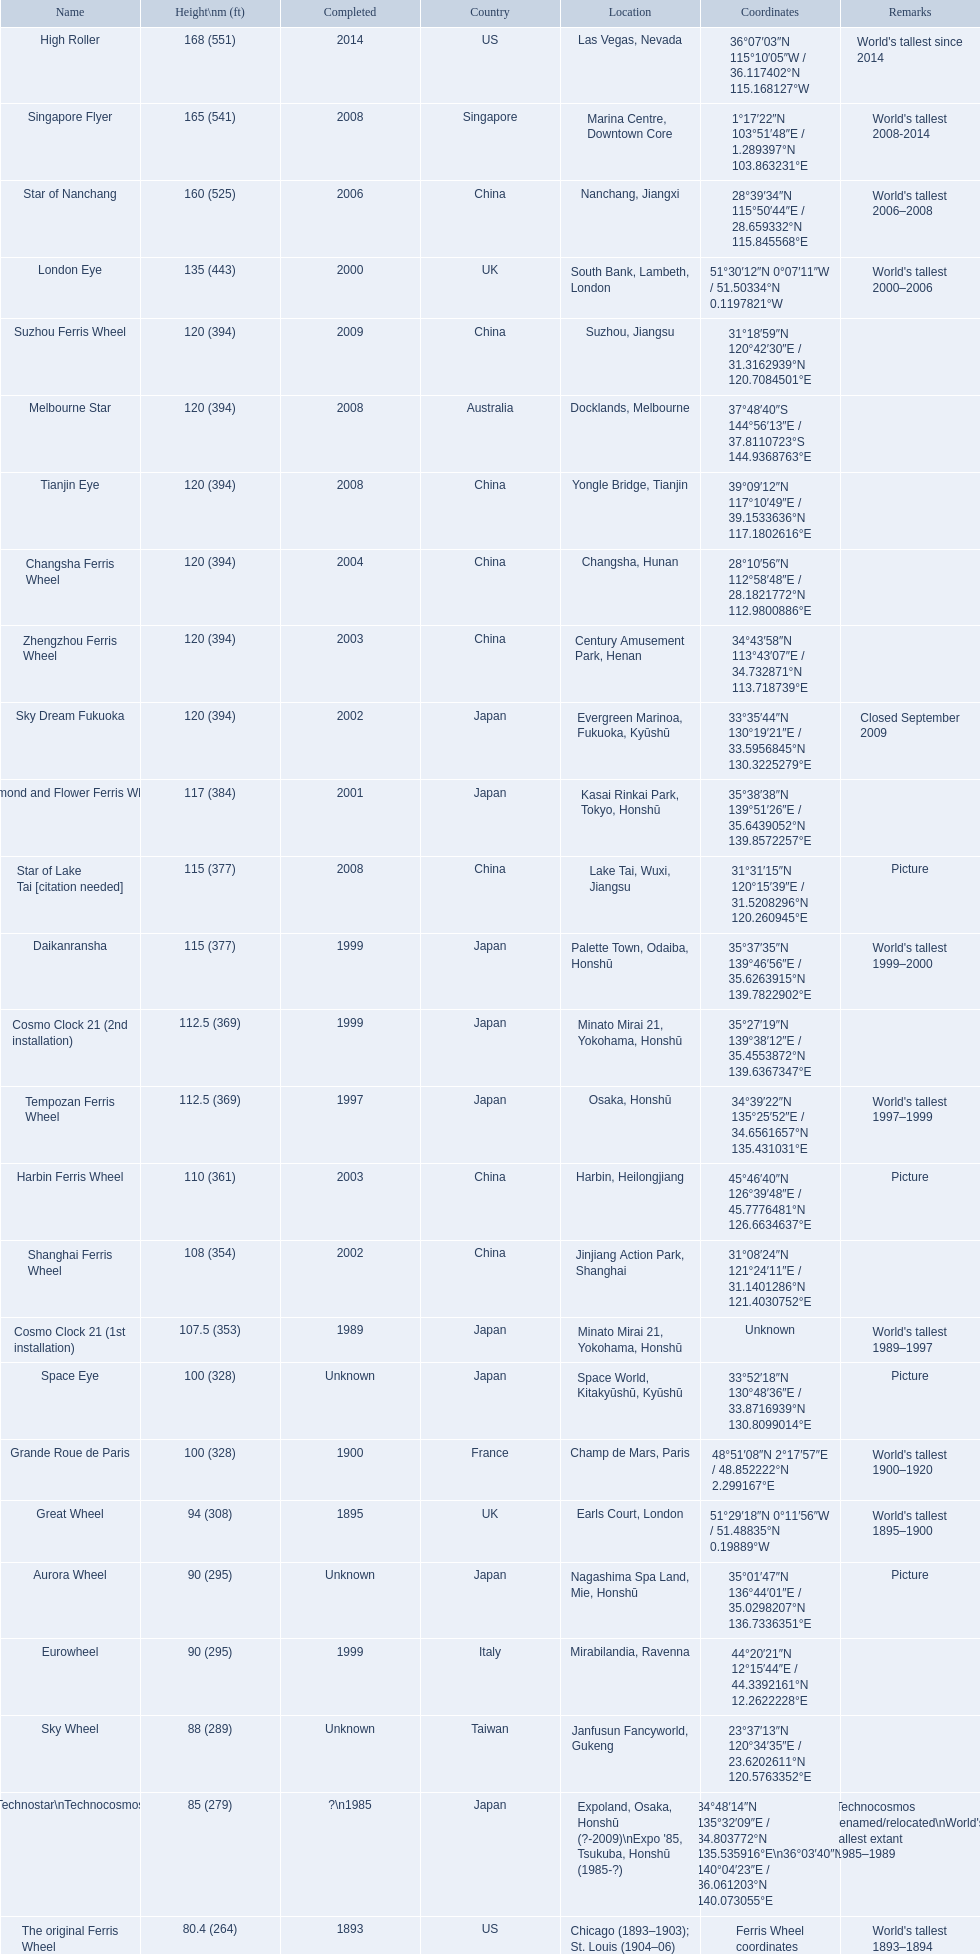What are the diverse finalization dates for the ferris wheel list? 2014, 2008, 2006, 2000, 2009, 2008, 2008, 2004, 2003, 2002, 2001, 2008, 1999, 1999, 1997, 2003, 2002, 1989, Unknown, 1900, 1895, Unknown, 1999, Unknown, ?\n1985, 1893. Which dates for the star of lake tai, star of nanchang, melbourne star? 2006, 2008, 2008. Which is the oldest? 2006. What is the designation of this ride? Star of Nanchang. 